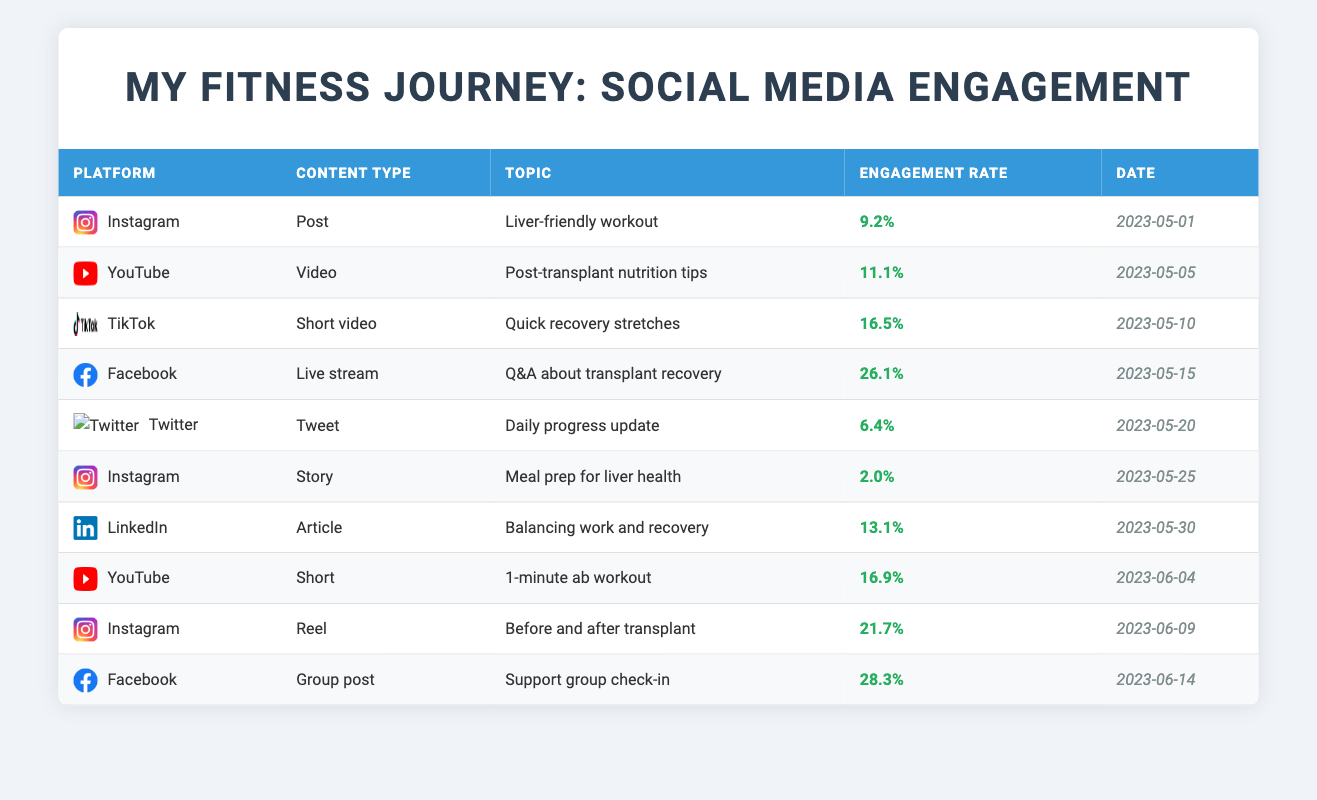What is the highest engagement rate among the posts listed? By reviewing the engagement rates in the table, the highest value is found in the Facebook group post with an engagement rate of 28.3%.
Answer: 28.3% Which platform had the least engagement rate? From the engagement rates presented in the table, the Instagram story related to meal prep for liver health has the lowest engagement rate at 2.0%.
Answer: 2.0% How many likes did the TikTok post about quick recovery stretches receive? The TikTok post on quick recovery stretches received 3200 likes, as indicated in the respective row of the table.
Answer: 3200 What is the average engagement rate across all the platforms? The engagement rates are 9.2, 11.1, 16.5, 26.1, 6.4, 2.0, 13.1, 16.9, 21.7, and 28.3, which sum up to 125.8. Dividing this by 10 (the number of posts) gives an average engagement rate of 12.58%.
Answer: 12.58% Did the post about post-transplant nutrition tips on YouTube have more views than the Instagram post on liver-friendly workouts? The YouTube video about nutrition tips received 5600 views compared to 1245 views for the Instagram post on liver-friendly workouts; hence, it is true that the YouTube video had more views.
Answer: Yes Which content type performed the best in terms of engagement rate? Analyzing the engagement rates by content type, the Facebook live stream about transplant recovery peaked at 26.1%, indicating it performed the best in engagement rate.
Answer: Live stream How many shares did the Instagram reel about before and after transplant get? According to the table, the Instagram reel post received 1200 shares, as noted in its respective row.
Answer: 1200 What is the difference in likes between the Facebook group post and the TikTok short video? The Facebook group post had 678 likes while the TikTok short video received 3200 likes. The difference is 3200 - 678 = 2522.
Answer: 2522 